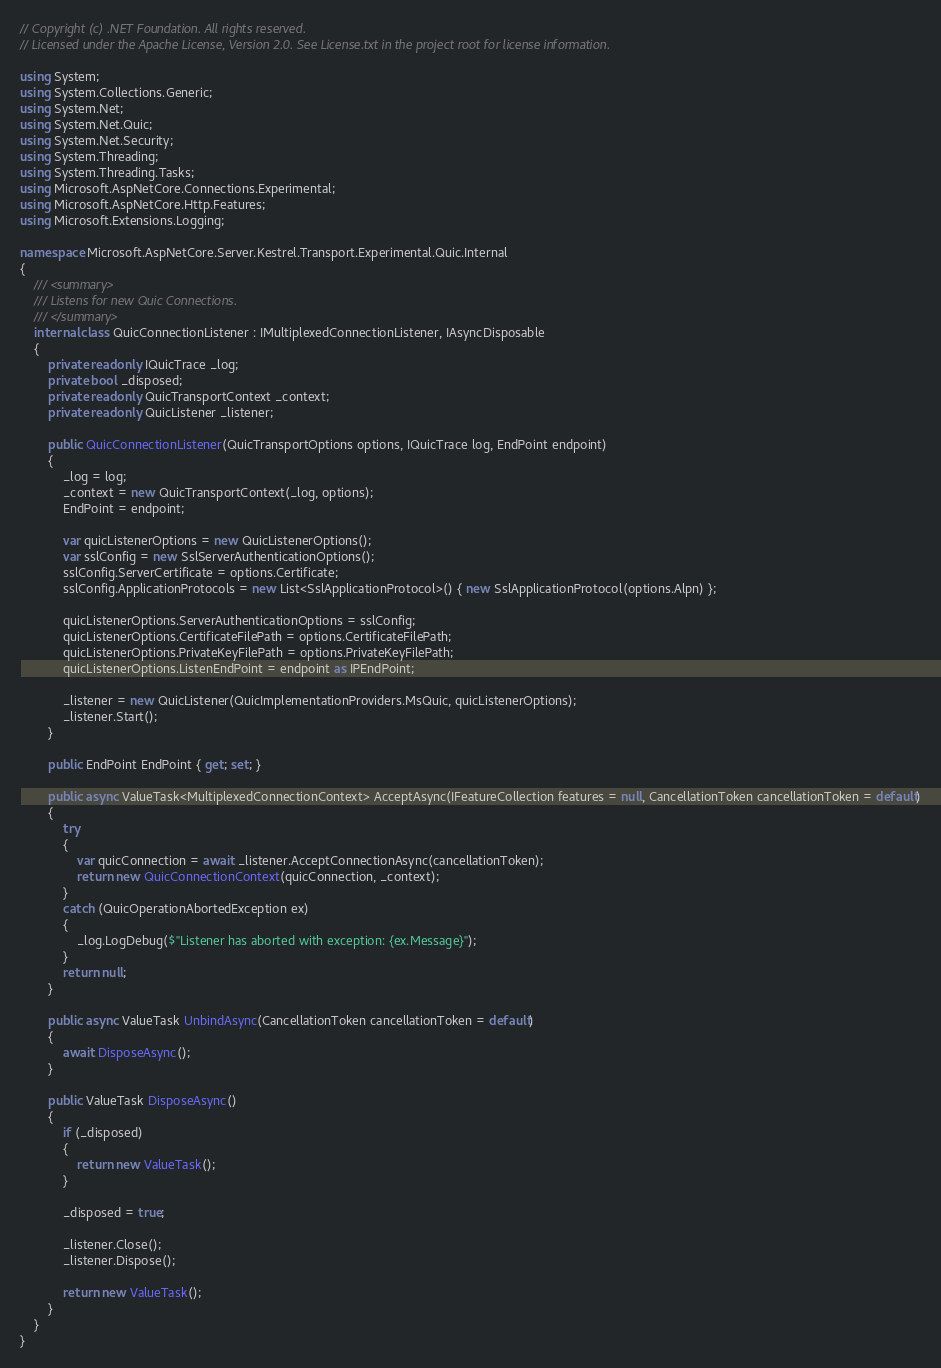Convert code to text. <code><loc_0><loc_0><loc_500><loc_500><_C#_>// Copyright (c) .NET Foundation. All rights reserved.
// Licensed under the Apache License, Version 2.0. See License.txt in the project root for license information.

using System;
using System.Collections.Generic;
using System.Net;
using System.Net.Quic;
using System.Net.Security;
using System.Threading;
using System.Threading.Tasks;
using Microsoft.AspNetCore.Connections.Experimental;
using Microsoft.AspNetCore.Http.Features;
using Microsoft.Extensions.Logging;

namespace Microsoft.AspNetCore.Server.Kestrel.Transport.Experimental.Quic.Internal
{
    /// <summary>
    /// Listens for new Quic Connections.
    /// </summary>
    internal class QuicConnectionListener : IMultiplexedConnectionListener, IAsyncDisposable
    {
        private readonly IQuicTrace _log;
        private bool _disposed;
        private readonly QuicTransportContext _context;
        private readonly QuicListener _listener;

        public QuicConnectionListener(QuicTransportOptions options, IQuicTrace log, EndPoint endpoint)
        {
            _log = log;
            _context = new QuicTransportContext(_log, options);
            EndPoint = endpoint;

            var quicListenerOptions = new QuicListenerOptions();
            var sslConfig = new SslServerAuthenticationOptions();
            sslConfig.ServerCertificate = options.Certificate;
            sslConfig.ApplicationProtocols = new List<SslApplicationProtocol>() { new SslApplicationProtocol(options.Alpn) };

            quicListenerOptions.ServerAuthenticationOptions = sslConfig;
            quicListenerOptions.CertificateFilePath = options.CertificateFilePath;
            quicListenerOptions.PrivateKeyFilePath = options.PrivateKeyFilePath;
            quicListenerOptions.ListenEndPoint = endpoint as IPEndPoint;

            _listener = new QuicListener(QuicImplementationProviders.MsQuic, quicListenerOptions);
            _listener.Start();
        }

        public EndPoint EndPoint { get; set; }

        public async ValueTask<MultiplexedConnectionContext> AcceptAsync(IFeatureCollection features = null, CancellationToken cancellationToken = default)
        {
            try
            {
                var quicConnection = await _listener.AcceptConnectionAsync(cancellationToken);
                return new QuicConnectionContext(quicConnection, _context);
            }
            catch (QuicOperationAbortedException ex)
            {
                _log.LogDebug($"Listener has aborted with exception: {ex.Message}");
            }
            return null;
        }

        public async ValueTask UnbindAsync(CancellationToken cancellationToken = default)
        {
            await DisposeAsync();
        }

        public ValueTask DisposeAsync()
        {
            if (_disposed)
            {
                return new ValueTask();
            }

            _disposed = true;

            _listener.Close();
            _listener.Dispose();

            return new ValueTask();
        }
    }
}
</code> 